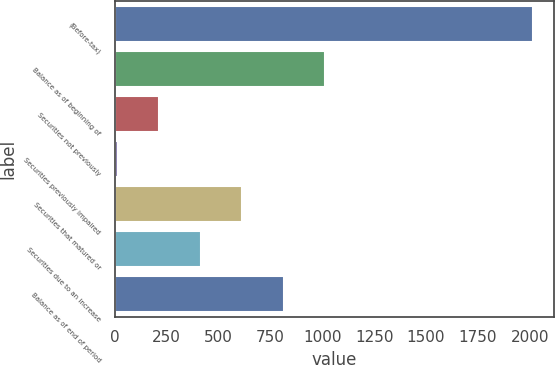<chart> <loc_0><loc_0><loc_500><loc_500><bar_chart><fcel>(Before-tax)<fcel>Balance as of beginning of<fcel>Securities not previously<fcel>Securities previously impaired<fcel>Securities that matured or<fcel>Securities due to an increase<fcel>Balance as of end of period<nl><fcel>2015<fcel>1014.5<fcel>214.1<fcel>14<fcel>614.3<fcel>414.2<fcel>814.4<nl></chart> 